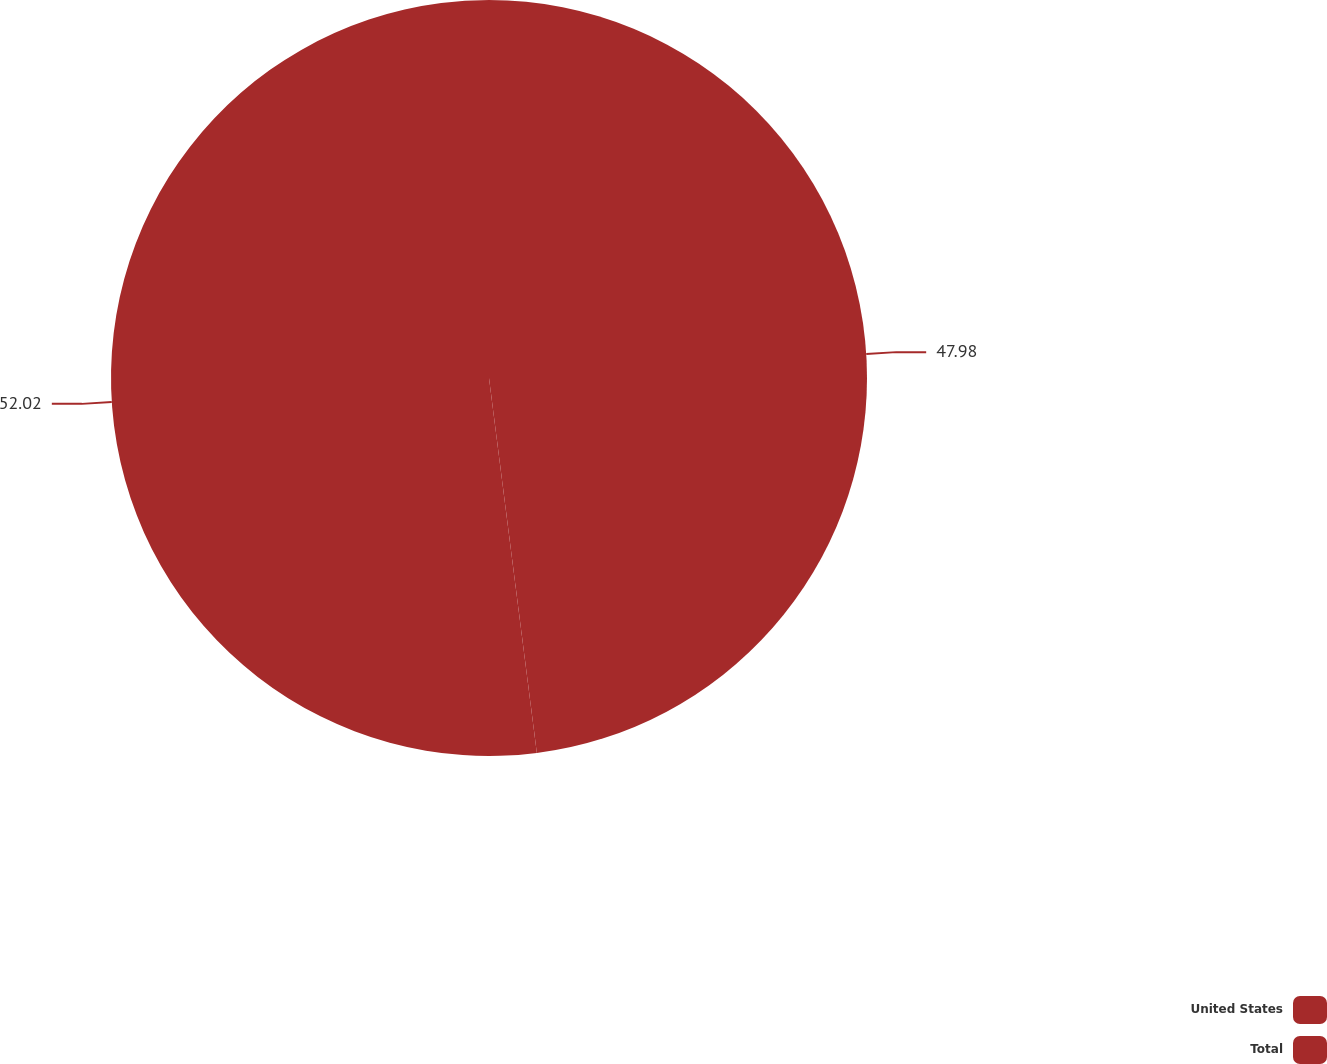<chart> <loc_0><loc_0><loc_500><loc_500><pie_chart><fcel>United States<fcel>Total<nl><fcel>47.98%<fcel>52.02%<nl></chart> 